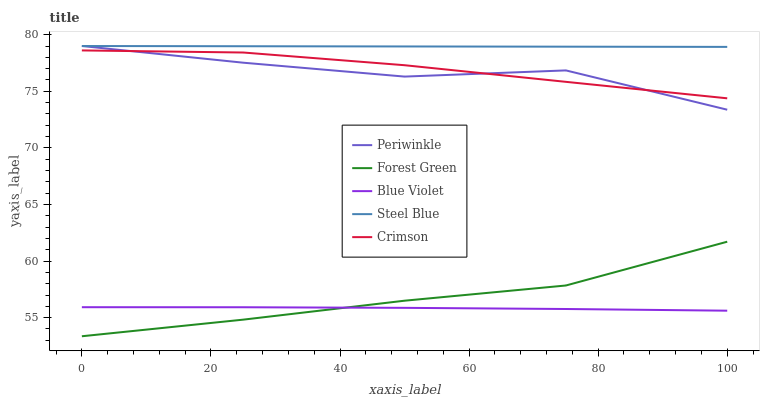Does Blue Violet have the minimum area under the curve?
Answer yes or no. Yes. Does Steel Blue have the maximum area under the curve?
Answer yes or no. Yes. Does Forest Green have the minimum area under the curve?
Answer yes or no. No. Does Forest Green have the maximum area under the curve?
Answer yes or no. No. Is Steel Blue the smoothest?
Answer yes or no. Yes. Is Periwinkle the roughest?
Answer yes or no. Yes. Is Forest Green the smoothest?
Answer yes or no. No. Is Forest Green the roughest?
Answer yes or no. No. Does Forest Green have the lowest value?
Answer yes or no. Yes. Does Periwinkle have the lowest value?
Answer yes or no. No. Does Steel Blue have the highest value?
Answer yes or no. Yes. Does Forest Green have the highest value?
Answer yes or no. No. Is Forest Green less than Steel Blue?
Answer yes or no. Yes. Is Steel Blue greater than Forest Green?
Answer yes or no. Yes. Does Crimson intersect Periwinkle?
Answer yes or no. Yes. Is Crimson less than Periwinkle?
Answer yes or no. No. Is Crimson greater than Periwinkle?
Answer yes or no. No. Does Forest Green intersect Steel Blue?
Answer yes or no. No. 